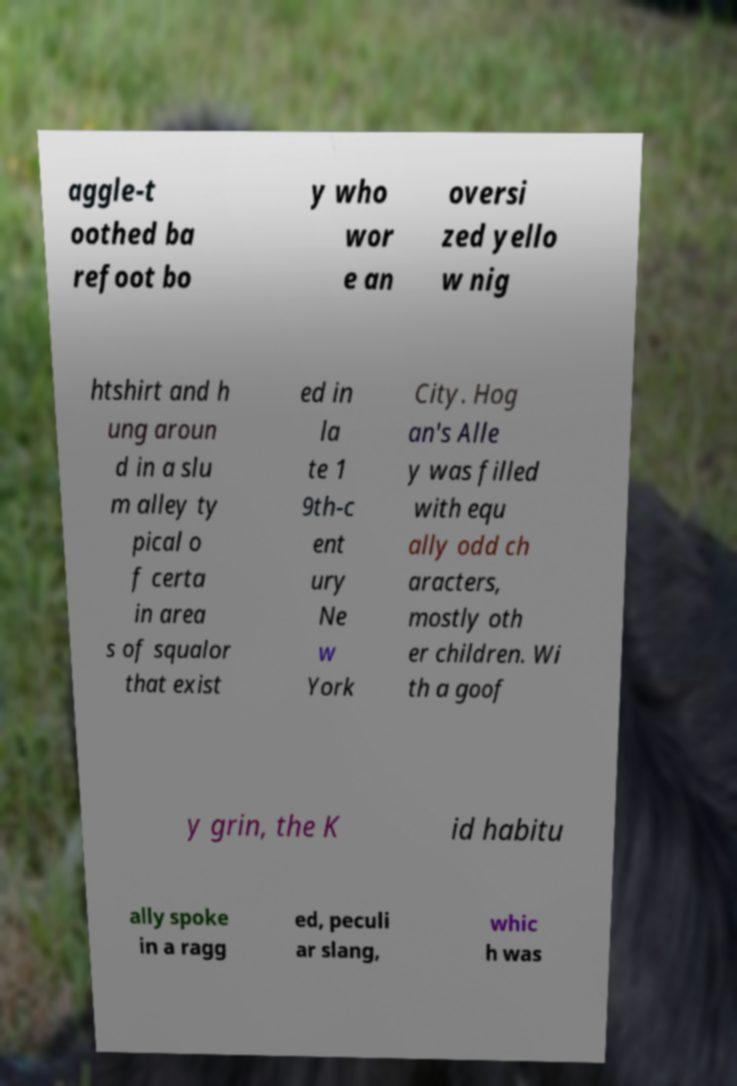I need the written content from this picture converted into text. Can you do that? aggle-t oothed ba refoot bo y who wor e an oversi zed yello w nig htshirt and h ung aroun d in a slu m alley ty pical o f certa in area s of squalor that exist ed in la te 1 9th-c ent ury Ne w York City. Hog an's Alle y was filled with equ ally odd ch aracters, mostly oth er children. Wi th a goof y grin, the K id habitu ally spoke in a ragg ed, peculi ar slang, whic h was 